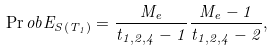<formula> <loc_0><loc_0><loc_500><loc_500>\Pr o b { E _ { S ( T _ { 1 } ) } } = \frac { M _ { e } } { t _ { 1 , 2 , 4 } - 1 } \frac { M _ { e } - 1 } { t _ { 1 , 2 , 4 } - 2 } ,</formula> 